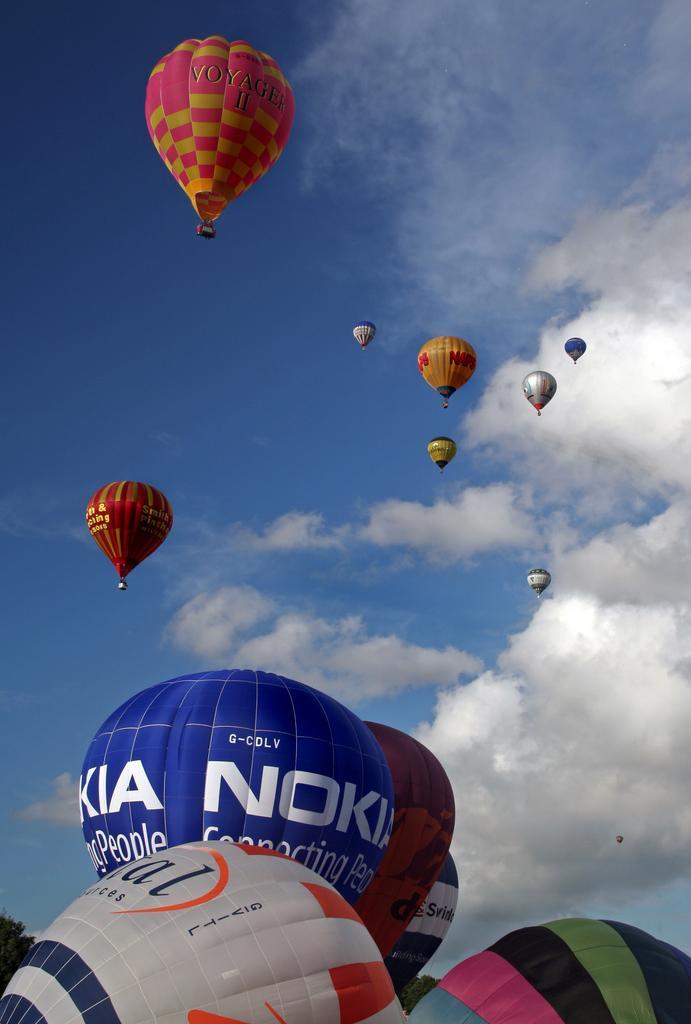Please provide a concise description of this image. In this image, we can see some hot air balloons. There are clouds in the sky. 